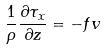<formula> <loc_0><loc_0><loc_500><loc_500>\frac { 1 } { \rho } \frac { \partial \tau _ { x } } { \partial z } = - f v</formula> 